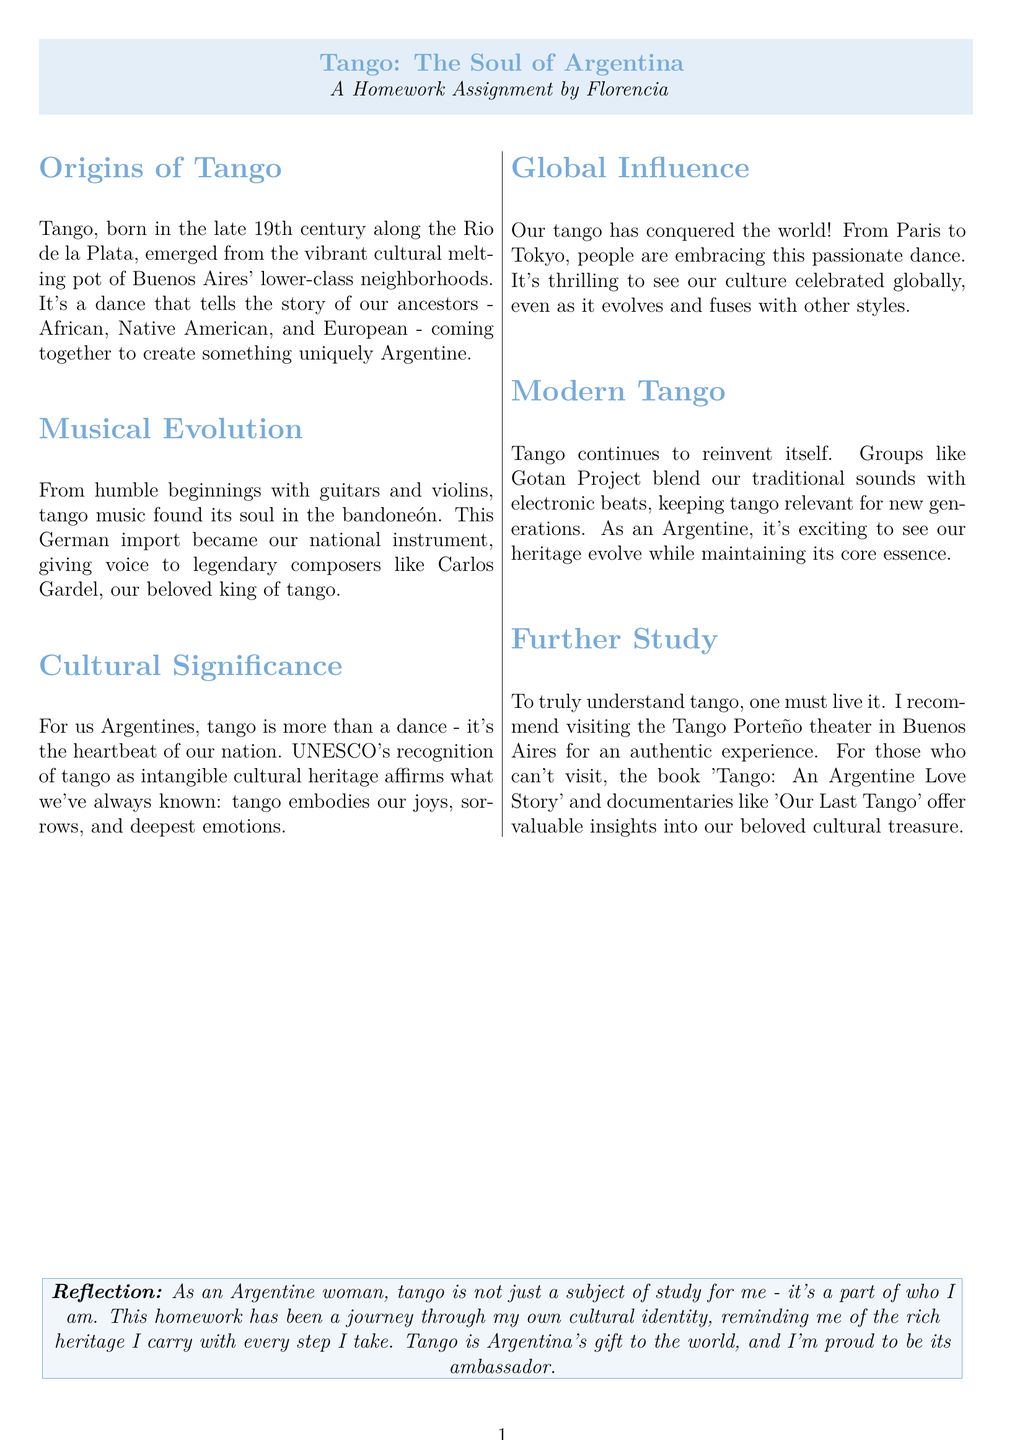What century did tango originate? Tangos origins begun in the late 19th century, as stated in the document.
Answer: 19th century What instrument is considered the national instrument of Argentina? The document states that the bandoneón, a German import, became Argentina's national instrument.
Answer: Bandoneón Who is referred to as the king of tango? Carlos Gardel is mentioned in the document as the beloved king of tango.
Answer: Carlos Gardel Which city is the heart of tango's origins? The document highlights that tango was born in Buenos Aires' neighborhoods.
Answer: Buenos Aires What kind of heritage does tango embody according to UNESCO? The document mentions that tango is recognized as intangible cultural heritage by UNESCO.
Answer: Intangible cultural heritage What modern group is mentioned as blending traditional tango with contemporary styles? The document references Gotan Project as a group that mixes traditional tango with electronic beats.
Answer: Gotan Project What is Florencia's recommendation for experiencing tango? The document suggests visiting the Tango Porteño theater in Buenos Aires for an authentic tango experience.
Answer: Tango Porteño theater What does tango represent for Florencia personally? Florencia expresses that tango is part of her cultural identity and who she is.
Answer: A part of who I am What is the title of the suggested book for deeper insight into tango? The document mentions 'Tango: An Argentine Love Story' as a recommended book for further study.
Answer: Tango: An Argentine Love Story 